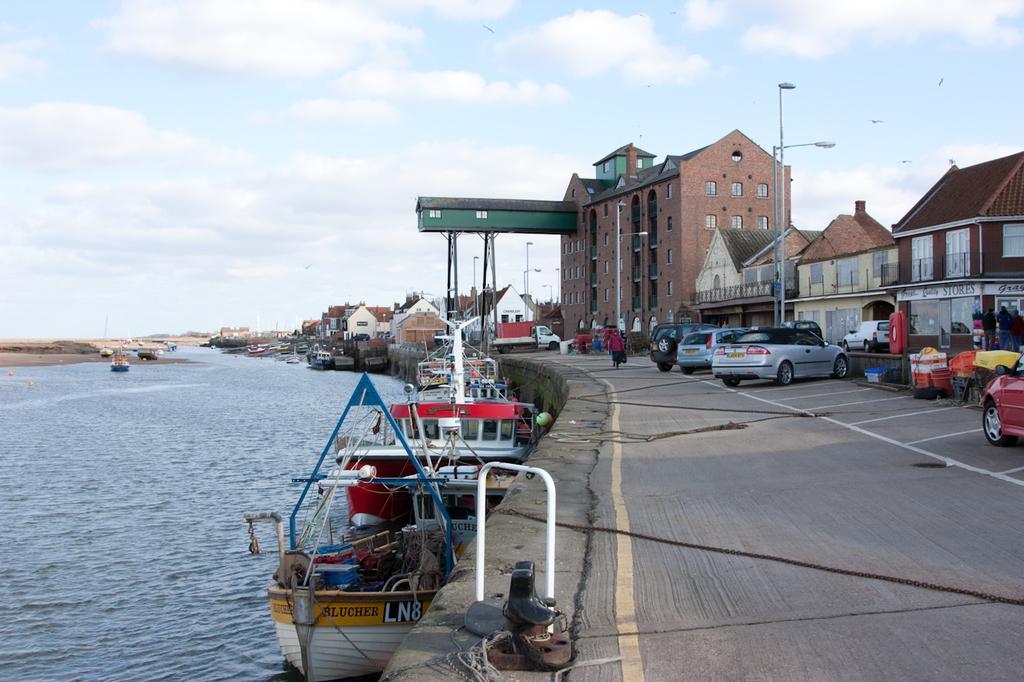Could you give a brief overview of what you see in this image? In this image, I can see the buildings and the vehicles on the road. There are two street lights in front of the buildings. I can see the boats on the water. In the background, there is the sky. 